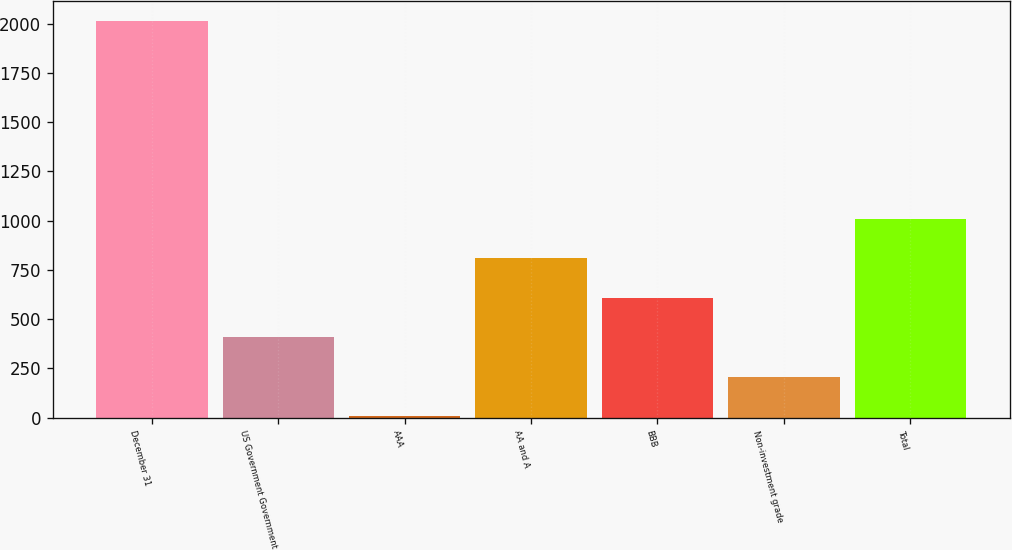<chart> <loc_0><loc_0><loc_500><loc_500><bar_chart><fcel>December 31<fcel>US Government Government<fcel>AAA<fcel>AA and A<fcel>BBB<fcel>Non-investment grade<fcel>Total<nl><fcel>2013<fcel>407.96<fcel>6.7<fcel>809.22<fcel>608.59<fcel>207.33<fcel>1009.85<nl></chart> 